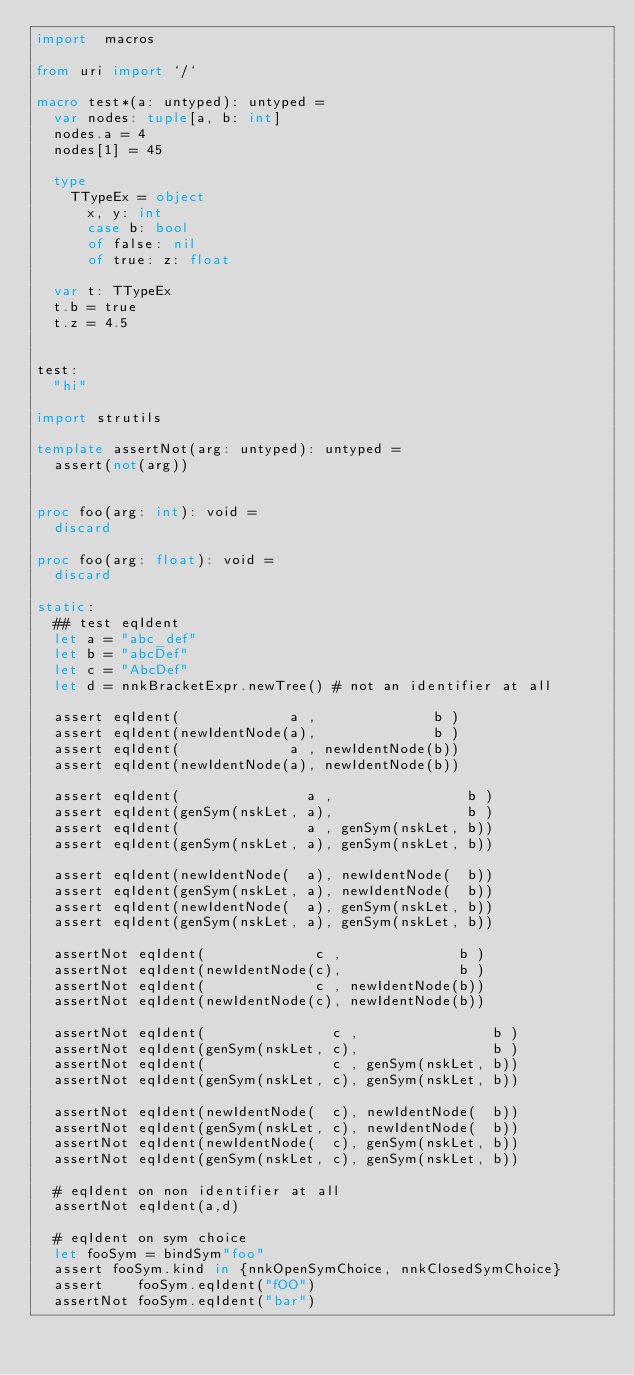<code> <loc_0><loc_0><loc_500><loc_500><_Nim_>import  macros

from uri import `/`

macro test*(a: untyped): untyped =
  var nodes: tuple[a, b: int]
  nodes.a = 4
  nodes[1] = 45

  type
    TTypeEx = object
      x, y: int
      case b: bool
      of false: nil
      of true: z: float

  var t: TTypeEx
  t.b = true
  t.z = 4.5


test:
  "hi"

import strutils

template assertNot(arg: untyped): untyped =
  assert(not(arg))


proc foo(arg: int): void =
  discard

proc foo(arg: float): void =
  discard

static:
  ## test eqIdent
  let a = "abc_def"
  let b = "abcDef"
  let c = "AbcDef"
  let d = nnkBracketExpr.newTree() # not an identifier at all

  assert eqIdent(             a ,              b )
  assert eqIdent(newIdentNode(a),              b )
  assert eqIdent(             a , newIdentNode(b))
  assert eqIdent(newIdentNode(a), newIdentNode(b))

  assert eqIdent(               a ,                b )
  assert eqIdent(genSym(nskLet, a),                b )
  assert eqIdent(               a , genSym(nskLet, b))
  assert eqIdent(genSym(nskLet, a), genSym(nskLet, b))

  assert eqIdent(newIdentNode(  a), newIdentNode(  b))
  assert eqIdent(genSym(nskLet, a), newIdentNode(  b))
  assert eqIdent(newIdentNode(  a), genSym(nskLet, b))
  assert eqIdent(genSym(nskLet, a), genSym(nskLet, b))

  assertNot eqIdent(             c ,              b )
  assertNot eqIdent(newIdentNode(c),              b )
  assertNot eqIdent(             c , newIdentNode(b))
  assertNot eqIdent(newIdentNode(c), newIdentNode(b))

  assertNot eqIdent(               c ,                b )
  assertNot eqIdent(genSym(nskLet, c),                b )
  assertNot eqIdent(               c , genSym(nskLet, b))
  assertNot eqIdent(genSym(nskLet, c), genSym(nskLet, b))

  assertNot eqIdent(newIdentNode(  c), newIdentNode(  b))
  assertNot eqIdent(genSym(nskLet, c), newIdentNode(  b))
  assertNot eqIdent(newIdentNode(  c), genSym(nskLet, b))
  assertNot eqIdent(genSym(nskLet, c), genSym(nskLet, b))

  # eqIdent on non identifier at all
  assertNot eqIdent(a,d)

  # eqIdent on sym choice
  let fooSym = bindSym"foo"
  assert fooSym.kind in {nnkOpenSymChoice, nnkClosedSymChoice}
  assert    fooSym.eqIdent("fOO")
  assertNot fooSym.eqIdent("bar")
</code> 